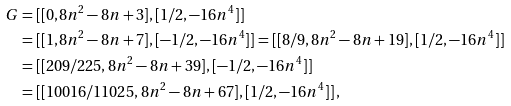Convert formula to latex. <formula><loc_0><loc_0><loc_500><loc_500>G & = [ [ 0 , 8 n ^ { 2 } - 8 n + 3 ] , [ 1 / 2 , - 1 6 n ^ { 4 } ] ] \\ & = [ [ 1 , 8 n ^ { 2 } - 8 n + 7 ] , [ - 1 / 2 , - 1 6 n ^ { 4 } ] ] = [ [ 8 / 9 , 8 n ^ { 2 } - 8 n + 1 9 ] , [ 1 / 2 , - 1 6 n ^ { 4 } ] ] \\ & = [ [ 2 0 9 / 2 2 5 , 8 n ^ { 2 } - 8 n + 3 9 ] , [ - 1 / 2 , - 1 6 n ^ { 4 } ] ] \\ & = [ [ 1 0 0 1 6 / 1 1 0 2 5 , 8 n ^ { 2 } - 8 n + 6 7 ] , [ 1 / 2 , - 1 6 n ^ { 4 } ] ] \, ,</formula> 